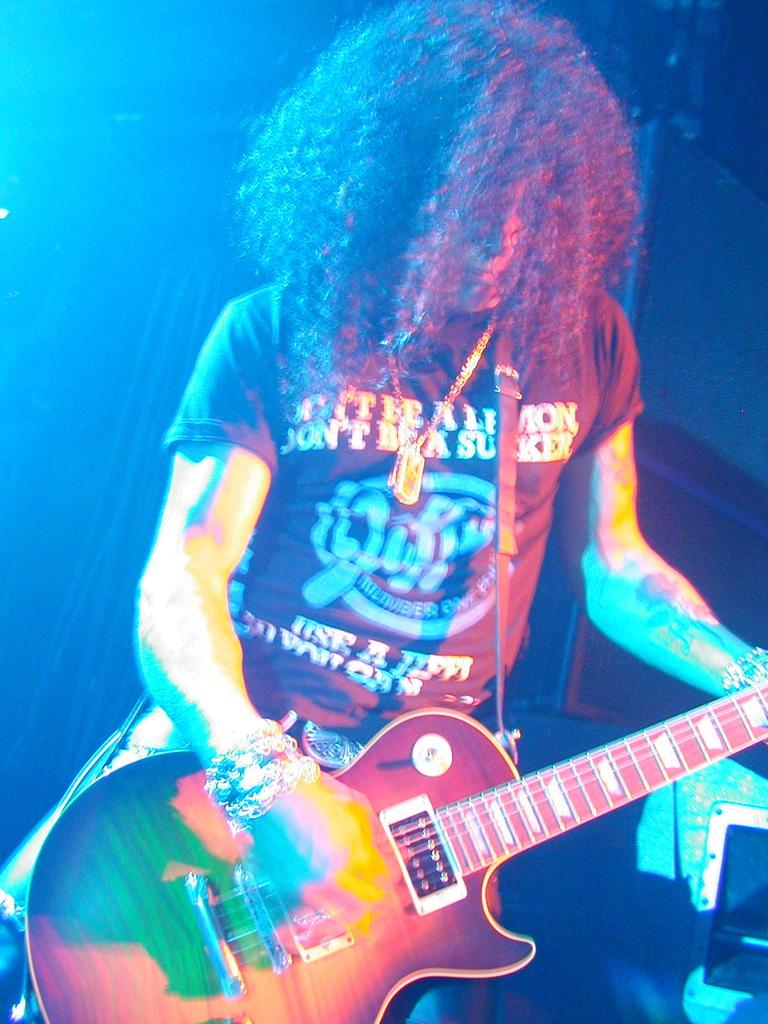What is the man in the image doing? The man is playing a guitar in the image. Can you describe any objects or items near the man? There is a box on the right side of the image. How many screws are visible on the guitar in the image? There is no mention of screws on the guitar in the image, so we cannot determine the number of screws. 